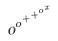<formula> <loc_0><loc_0><loc_500><loc_500>o ^ { o ^ { + ^ { + ^ { o ^ { x } } } } }</formula> 